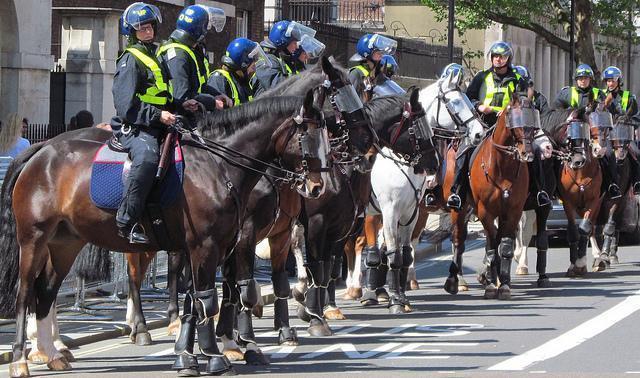Why do the horses wear leg coverings?
Answer the question by selecting the correct answer among the 4 following choices.
Options: Parade elevation, armor, decoration, digging tools. Armor. 